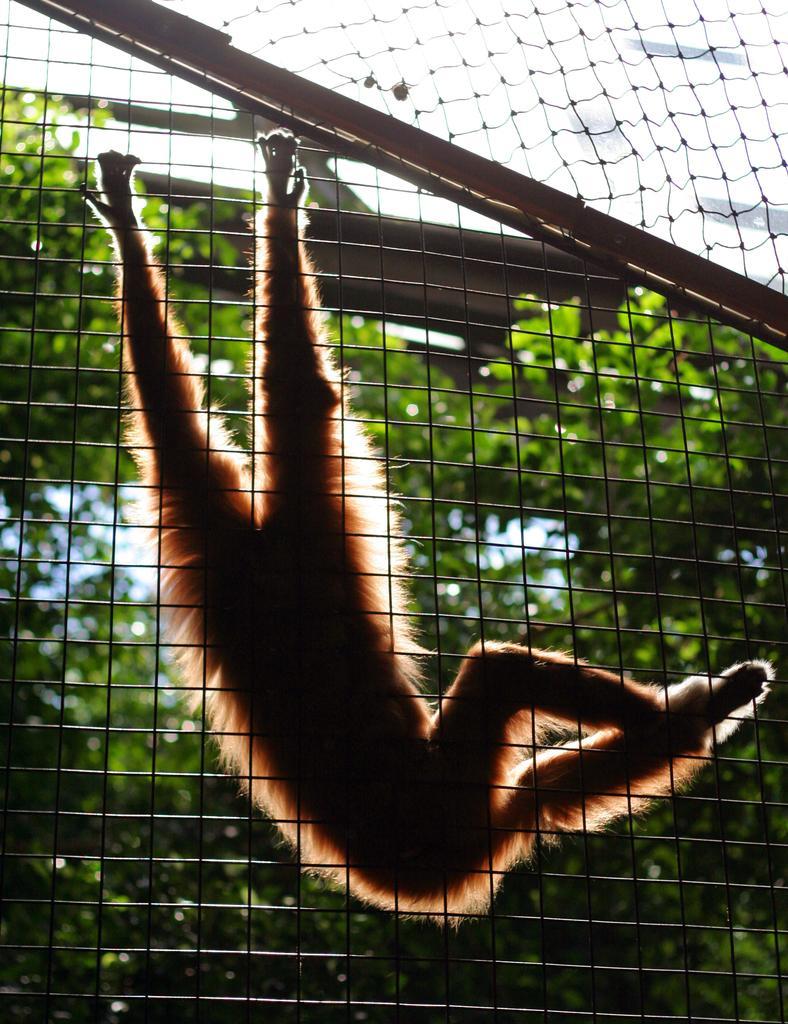Please provide a concise description of this image. In the image we can see an iron fencing on which there is a monkey who is holding it in upside down direction. Behind the monkey there are lot of trees. 